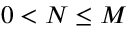<formula> <loc_0><loc_0><loc_500><loc_500>0 < N \leq M</formula> 